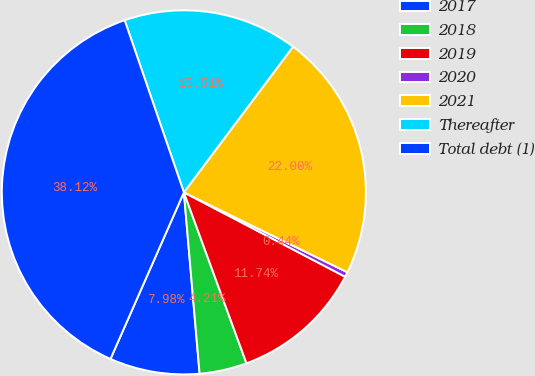Convert chart to OTSL. <chart><loc_0><loc_0><loc_500><loc_500><pie_chart><fcel>2017<fcel>2018<fcel>2019<fcel>2020<fcel>2021<fcel>Thereafter<fcel>Total debt (1)<nl><fcel>7.98%<fcel>4.21%<fcel>11.74%<fcel>0.44%<fcel>22.0%<fcel>15.51%<fcel>38.12%<nl></chart> 